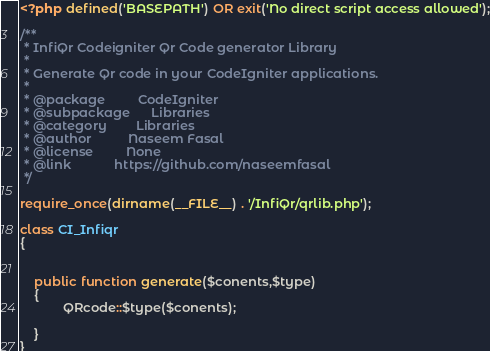Convert code to text. <code><loc_0><loc_0><loc_500><loc_500><_PHP_><?php defined('BASEPATH') OR exit('No direct script access allowed');

/**
 * InfiQr Codeigniter Qr Code generator Library
 *
 * Generate Qr code in your CodeIgniter applications.
 *
 * @package			CodeIgniter
 * @subpackage		Libraries
 * @category		Libraries
 * @author			Naseem Fasal
 * @license			None
 * @link			https://github.com/naseemfasal
 */

require_once(dirname(__FILE__) . '/InfiQr/qrlib.php');

class CI_Infiqr 
{


	public function generate($conents,$type)
	{
		    QRcode::$type($conents); 

	}
}
</code> 